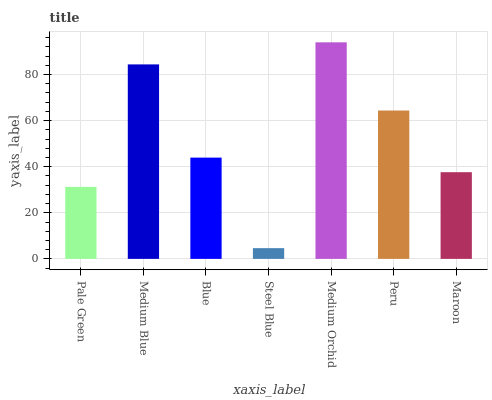Is Steel Blue the minimum?
Answer yes or no. Yes. Is Medium Orchid the maximum?
Answer yes or no. Yes. Is Medium Blue the minimum?
Answer yes or no. No. Is Medium Blue the maximum?
Answer yes or no. No. Is Medium Blue greater than Pale Green?
Answer yes or no. Yes. Is Pale Green less than Medium Blue?
Answer yes or no. Yes. Is Pale Green greater than Medium Blue?
Answer yes or no. No. Is Medium Blue less than Pale Green?
Answer yes or no. No. Is Blue the high median?
Answer yes or no. Yes. Is Blue the low median?
Answer yes or no. Yes. Is Peru the high median?
Answer yes or no. No. Is Pale Green the low median?
Answer yes or no. No. 